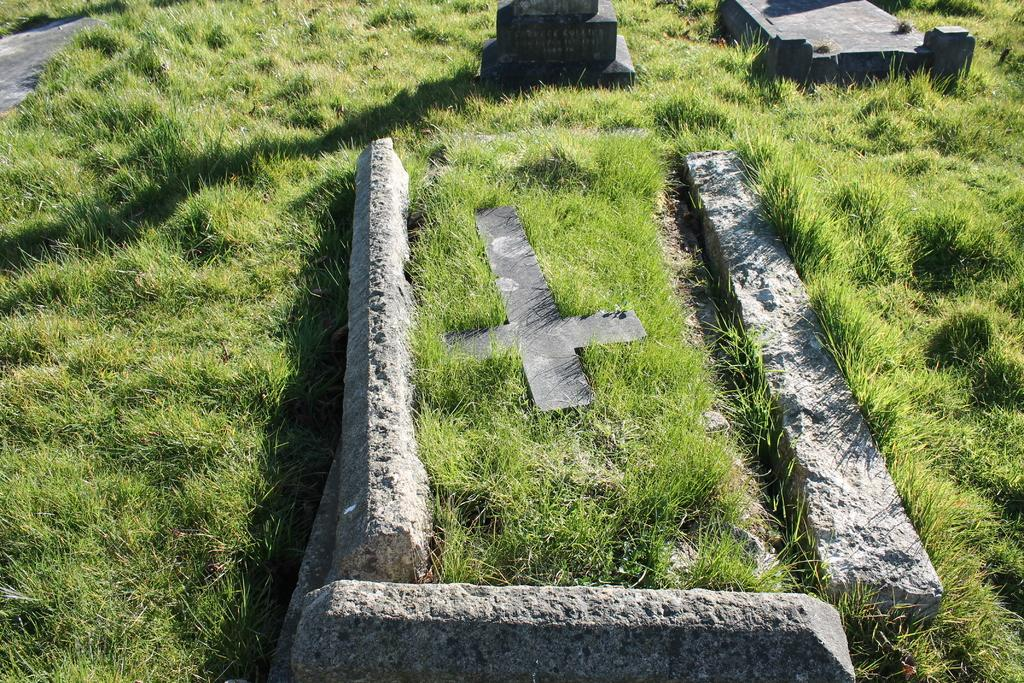What is the main setting of the image? The image depicts a graveyard. Can you describe the grave in the front of the image? There is a grave with a stone and a cross mark in the front. Are there any other graves visible in the image? Yes, there are additional grave stones behind the front grave. What type of fuel is being used to power the house in the image? There is no house present in the image, so it is not possible to determine what type of fuel might be used to power it. 